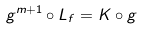<formula> <loc_0><loc_0><loc_500><loc_500>g ^ { m + 1 } \circ L _ { f } = K \circ g</formula> 